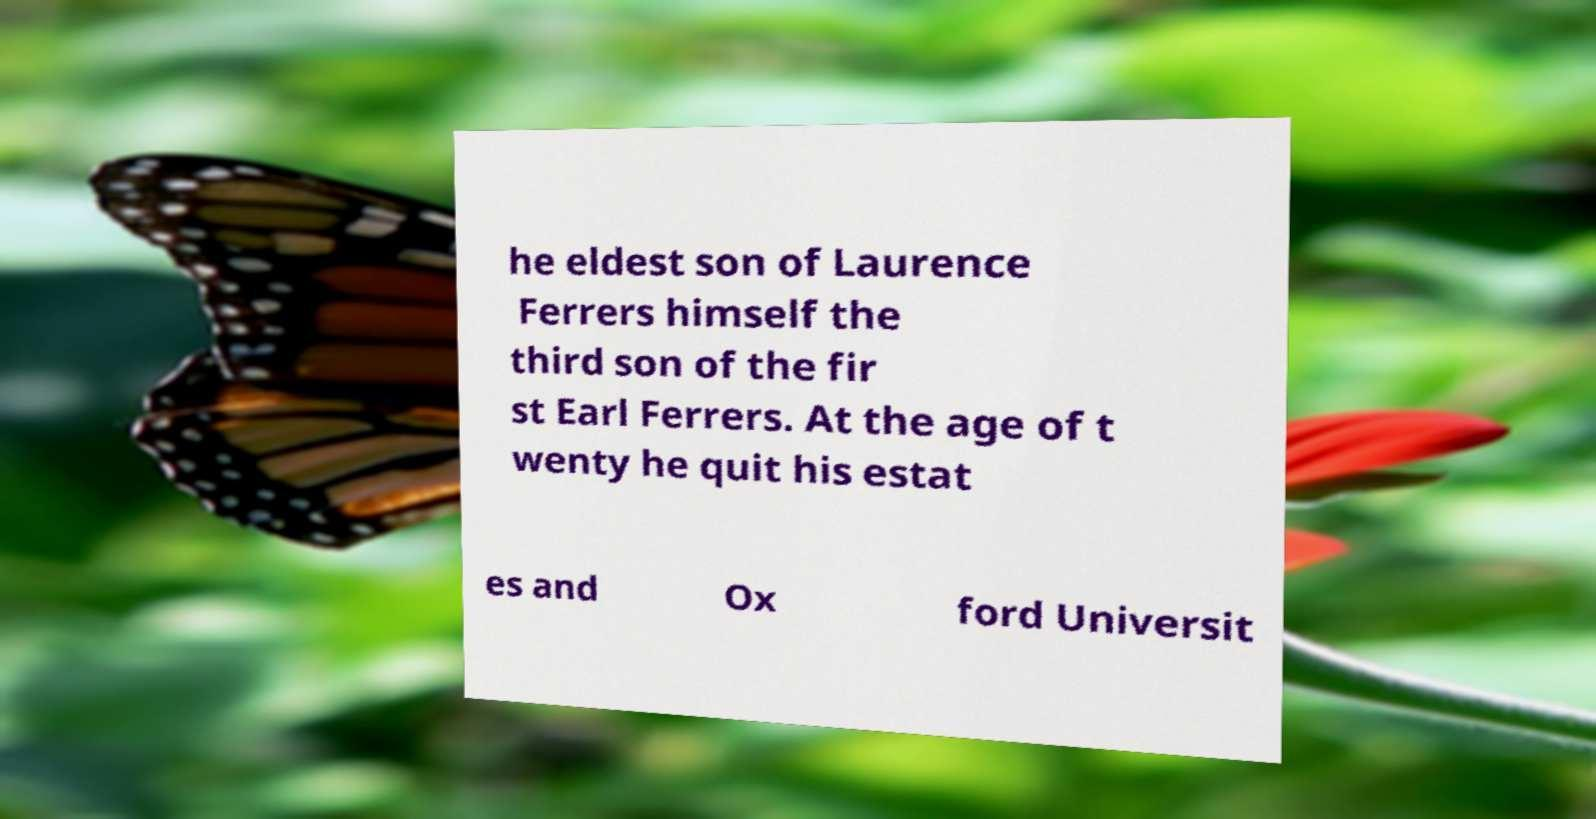For documentation purposes, I need the text within this image transcribed. Could you provide that? he eldest son of Laurence Ferrers himself the third son of the fir st Earl Ferrers. At the age of t wenty he quit his estat es and Ox ford Universit 